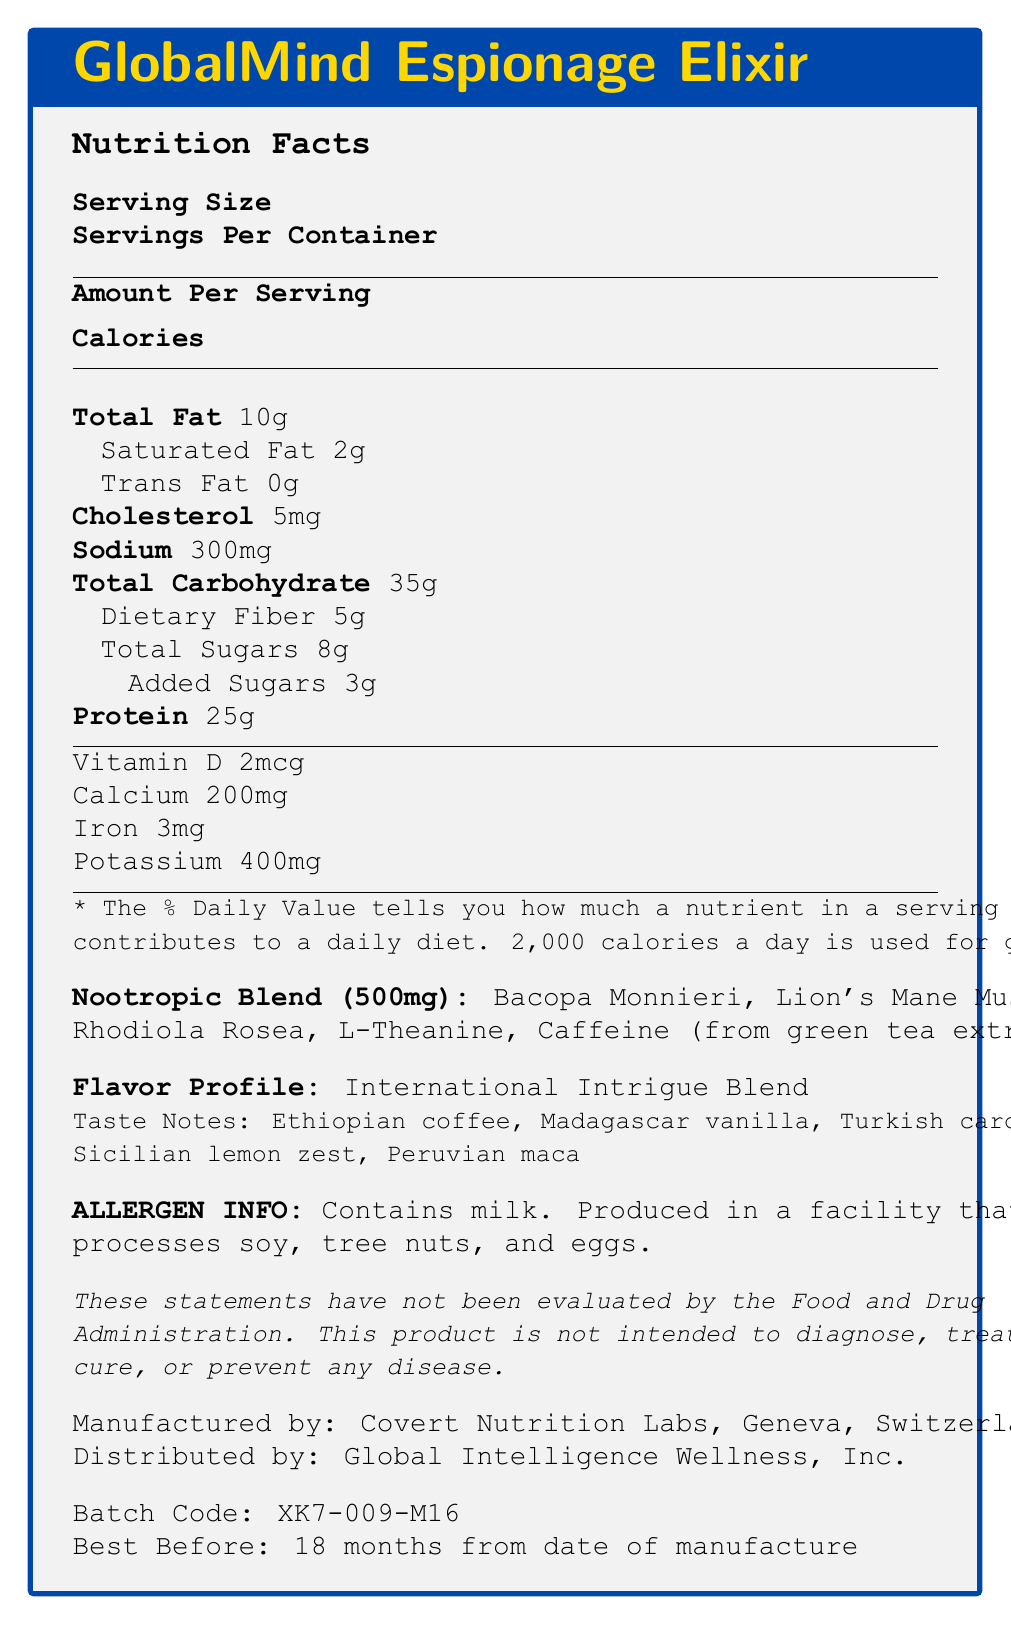what is the serving size for the GlobalMind Espionage Elixir? The document clearly states that the serving size is 1 bottle with a volume of 400ml.
Answer: 1 bottle (400ml) how many grams of protein are in one serving? According to the document under the protein section, 25g of protein is provided per serving.
Answer: 25g what is the percentage of daily value for dietary fiber? The document shows that dietary fiber contributes 18% to the daily value.
Answer: 18% which ingredients are part of the nootropic blend? The nootropic blend section of the document lists these ingredients.
Answer: Bacopa Monnieri, Lion's Mane Mushroom, Rhodiola Rosea, L-Theanine, Caffeine (from green tea extract) what are the taste notes mentioned in the document? These taste notes are specified under the “Taste Notes” section in the document.
Answer: Ethiopian coffee, Madagascar vanilla, Turkish cardamom, Sicilian lemon zest, Peruvian maca which vitamins and minerals are included in this meal replacement shake? A. Vitamin D, Calcium, Iron, Potassium B. Vitamin C, Magnesium, Calcium, Zinc C. Vitamin B, Iron, Potassium, Magnesium D. Vitamin A, Calcium, Zinc, Potassium The document mentions Vitamin D, Calcium, Iron, and Potassium as part of the nutrients.
Answer: A what is the daily value percentage for total fat? i. 8% ii. 10% iii. 13% iv. 15% The document indicates that the total fat content contributes 13% to the daily value.
Answer: iii. 13% does this product contain any allergens? It is stated in the allergen information section that the product contains milk and is produced in a facility that processes soy, tree nuts, and eggs.
Answer: Yes is this product intended to cure diseases? According to the disclaimer in the document, the product is not intended to diagnose, treat, cure, or prevent any disease.
Answer: No provide a summary of the document. The document provides detailed nutritional information and highlights the unique aspects of the GlobalMind Espionage Elixir, such as its flavors, ingredients, and health disclaimers, along with manufacturing and distribution details.
Answer: The GlobalMind Espionage Elixir is a gourmet meal replacement shake with 320 calories per serving and a complex flavor profile featuring ingredients like Ethiopian coffee and Sicilian lemon zest. It contains a nootropic blend of Bacopa Monnieri, Lion's Mane Mushroom, Rhodiola Rosea, L-Theanine, and Caffeine. The product is nutrient-rich with vitamins and minerals, including significant amounts of protein, fiber, cholesterol, and sodium. Produced in Switzerland and distributed globally, it carries allergen warnings for milk, soy, tree nuts, and eggs, and includes a disclaimer about its health claims. where is the product manufactured? The document states that the elixir is manufactured by Covert Nutrition Labs in Geneva, Switzerland.
Answer: Geneva, Switzerland what is the batch code for the current product? The batch code provided in the document is XK7-009-M16.
Answer: XK7-009-M16 what company distributes the product? As mentioned in the document, the product is distributed by Global Intelligence Wellness, Inc.
Answer: Global Intelligence Wellness, Inc. how long is the product shelf life after manufacturing? The document states the product is best before 18 months from the date of manufacture.
Answer: 18 months what type of fat does the product contain? The document specifies that the product contains 2g of saturated fat and 0g of trans fat.
Answer: Saturated Fat: 2g, Trans Fat: 0g how much caffeine is in the nootropic blend? While caffeine from green tea extract is listed as part of the nootropic blend, the exact amount is not provided in the document.
Answer: Not specified 